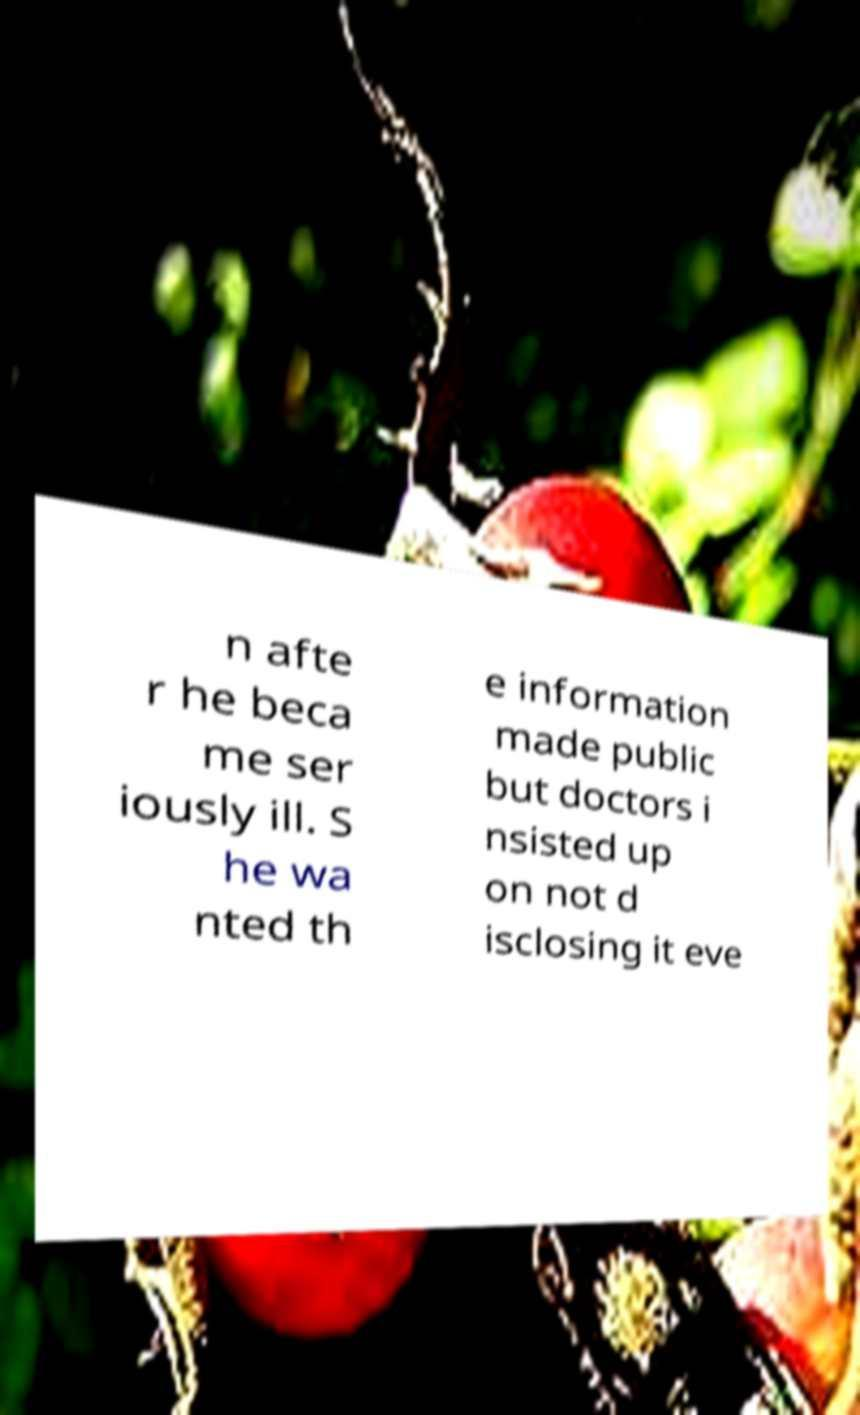Can you accurately transcribe the text from the provided image for me? n afte r he beca me ser iously ill. S he wa nted th e information made public but doctors i nsisted up on not d isclosing it eve 